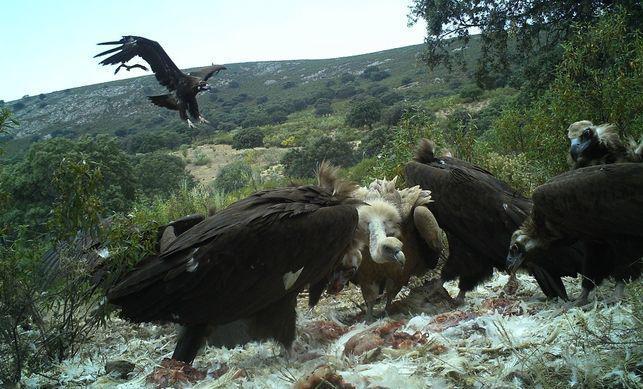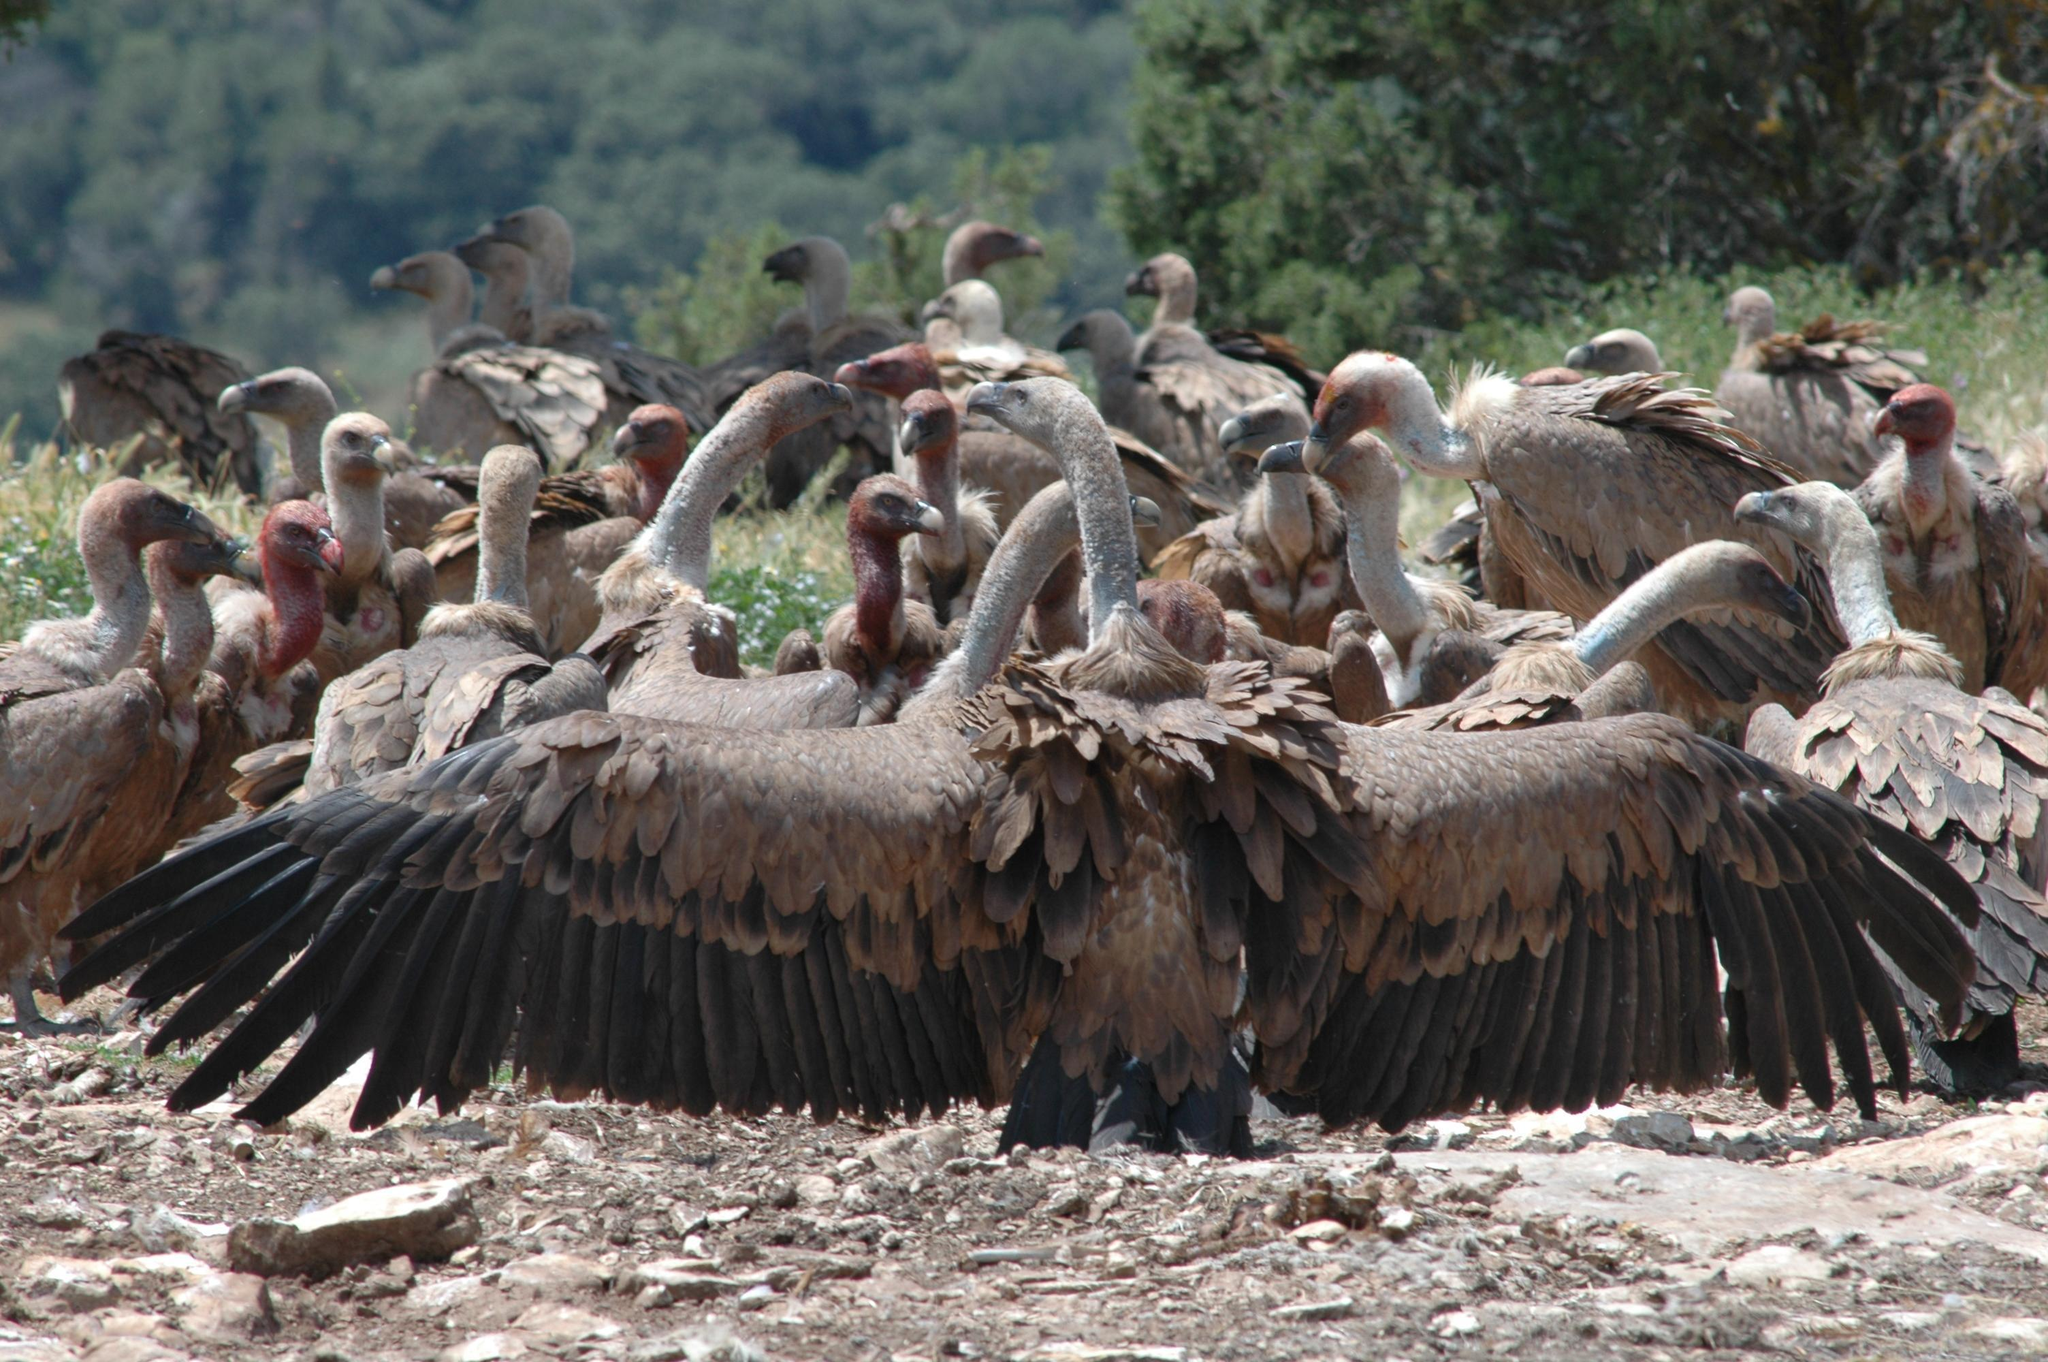The first image is the image on the left, the second image is the image on the right. Evaluate the accuracy of this statement regarding the images: "One of the images shows four vultures, while the other shows many more, and none of them are currently eating.". Is it true? Answer yes or no. No. 